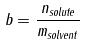<formula> <loc_0><loc_0><loc_500><loc_500>b = \frac { n _ { s o l u t e } } { m _ { s o l v e n t } }</formula> 